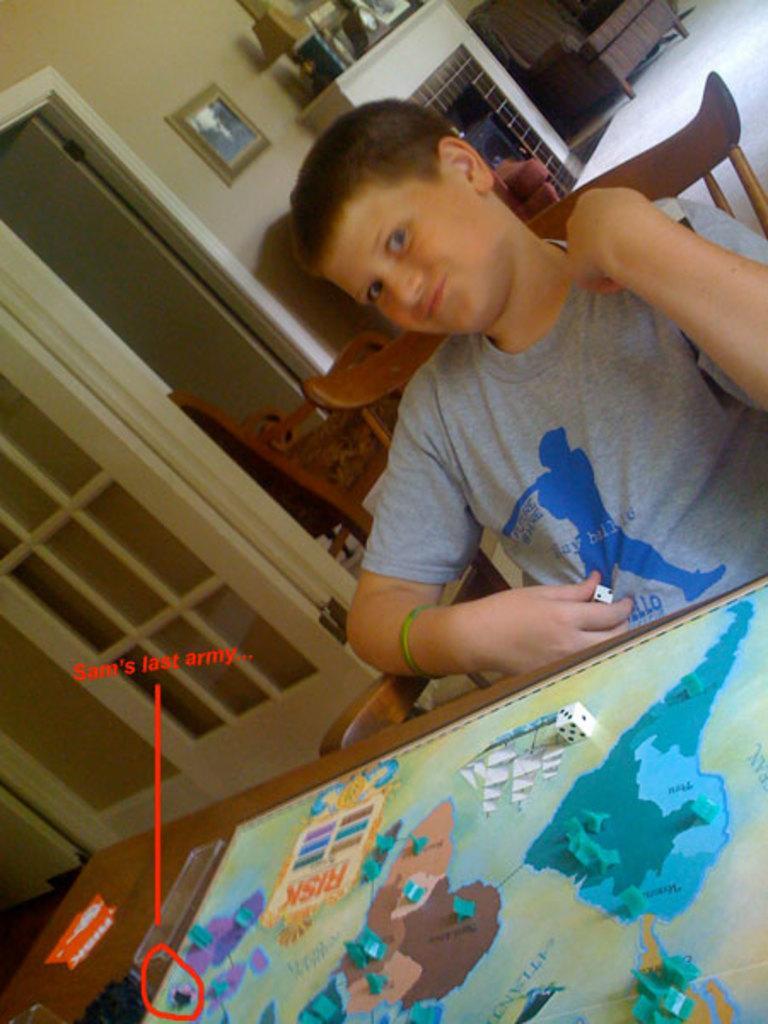Can you describe this image briefly? In this image we can see a person sitting on the chair, in front him there is a table with some objects on it, there are some chairs, doors and other objects and also we can see a wall with a photo frame. 